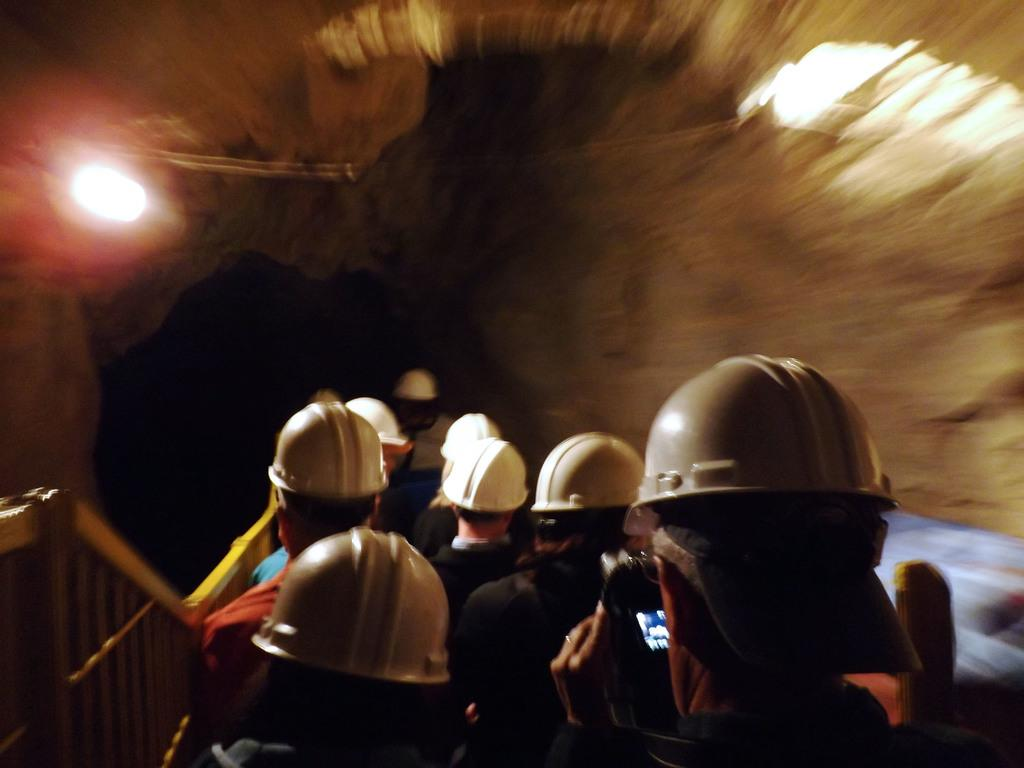How many people are in the image? There is a group of people in the image. What are the people wearing on their heads? The people are wearing helmets. Where are the people standing? The people are standing on a path. What is on the left side of the people? There is an iron fence on the left side of the people. What can be seen at the top of the image? There is a light visible at the top of the image. What rhythm are the people dancing to in the image? There is no indication in the image that the people are dancing, nor is there any mention of rhythm. 